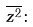<formula> <loc_0><loc_0><loc_500><loc_500>\overline { z ^ { 2 } } \colon</formula> 